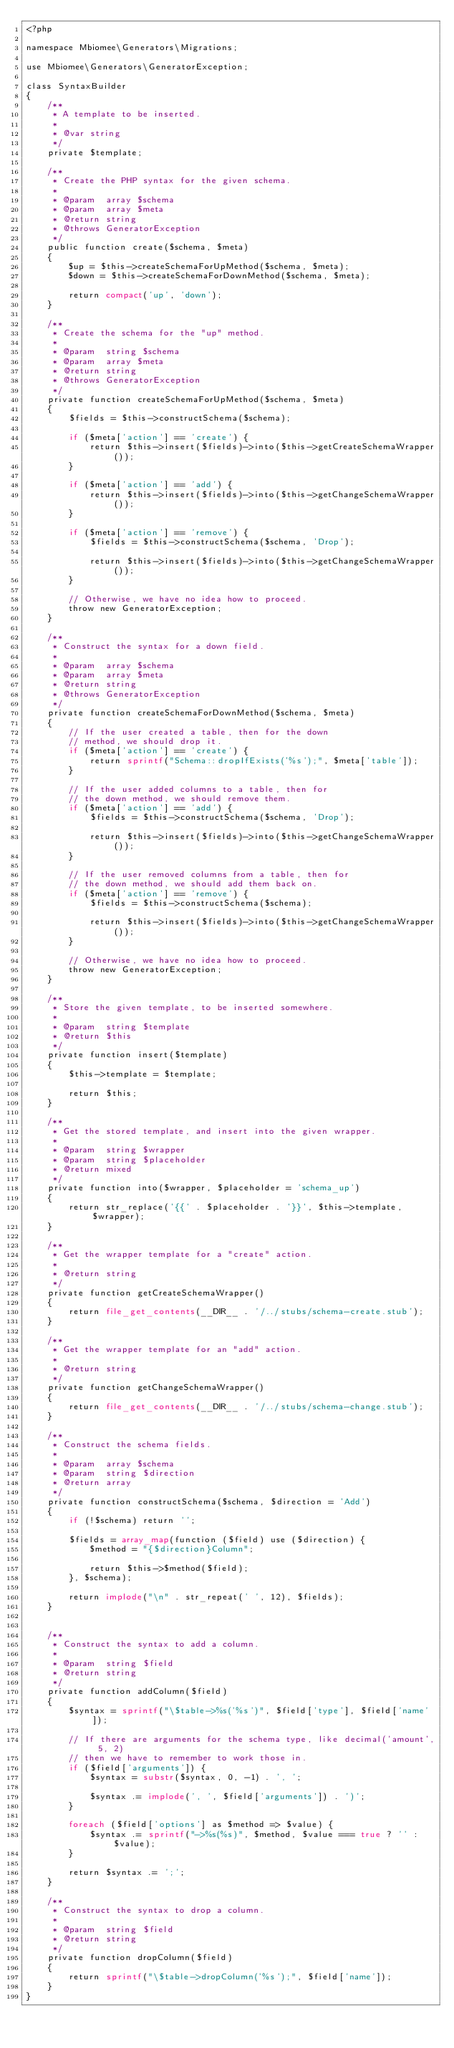<code> <loc_0><loc_0><loc_500><loc_500><_PHP_><?php

namespace Mbiomee\Generators\Migrations;

use Mbiomee\Generators\GeneratorException;

class SyntaxBuilder
{
    /**
     * A template to be inserted.
     *
     * @var string
     */
    private $template;

    /**
     * Create the PHP syntax for the given schema.
     *
     * @param  array $schema
     * @param  array $meta
     * @return string
     * @throws GeneratorException
     */
    public function create($schema, $meta)
    {
        $up = $this->createSchemaForUpMethod($schema, $meta);
        $down = $this->createSchemaForDownMethod($schema, $meta);

        return compact('up', 'down');
    }

    /**
     * Create the schema for the "up" method.
     *
     * @param  string $schema
     * @param  array $meta
     * @return string
     * @throws GeneratorException
     */
    private function createSchemaForUpMethod($schema, $meta)
    {
        $fields = $this->constructSchema($schema);

        if ($meta['action'] == 'create') {
            return $this->insert($fields)->into($this->getCreateSchemaWrapper());
        }

        if ($meta['action'] == 'add') {
            return $this->insert($fields)->into($this->getChangeSchemaWrapper());
        }

        if ($meta['action'] == 'remove') {
            $fields = $this->constructSchema($schema, 'Drop');

            return $this->insert($fields)->into($this->getChangeSchemaWrapper());
        }

        // Otherwise, we have no idea how to proceed.
        throw new GeneratorException;
    }

    /**
     * Construct the syntax for a down field.
     *
     * @param  array $schema
     * @param  array $meta
     * @return string
     * @throws GeneratorException
     */
    private function createSchemaForDownMethod($schema, $meta)
    {
        // If the user created a table, then for the down
        // method, we should drop it.
        if ($meta['action'] == 'create') {
            return sprintf("Schema::dropIfExists('%s');", $meta['table']);
        }

        // If the user added columns to a table, then for
        // the down method, we should remove them.
        if ($meta['action'] == 'add') {
            $fields = $this->constructSchema($schema, 'Drop');

            return $this->insert($fields)->into($this->getChangeSchemaWrapper());
        }

        // If the user removed columns from a table, then for
        // the down method, we should add them back on.
        if ($meta['action'] == 'remove') {
            $fields = $this->constructSchema($schema);

            return $this->insert($fields)->into($this->getChangeSchemaWrapper());
        }

        // Otherwise, we have no idea how to proceed.
        throw new GeneratorException;
    }

    /**
     * Store the given template, to be inserted somewhere.
     *
     * @param  string $template
     * @return $this
     */
    private function insert($template)
    {
        $this->template = $template;

        return $this;
    }

    /**
     * Get the stored template, and insert into the given wrapper.
     *
     * @param  string $wrapper
     * @param  string $placeholder
     * @return mixed
     */
    private function into($wrapper, $placeholder = 'schema_up')
    {
        return str_replace('{{' . $placeholder . '}}', $this->template, $wrapper);
    }

    /**
     * Get the wrapper template for a "create" action.
     *
     * @return string
     */
    private function getCreateSchemaWrapper()
    {
        return file_get_contents(__DIR__ . '/../stubs/schema-create.stub');
    }

    /**
     * Get the wrapper template for an "add" action.
     *
     * @return string
     */
    private function getChangeSchemaWrapper()
    {
        return file_get_contents(__DIR__ . '/../stubs/schema-change.stub');
    }

    /**
     * Construct the schema fields.
     *
     * @param  array $schema
     * @param  string $direction
     * @return array
     */
    private function constructSchema($schema, $direction = 'Add')
    {
        if (!$schema) return '';

        $fields = array_map(function ($field) use ($direction) {
            $method = "{$direction}Column";

            return $this->$method($field);
        }, $schema);

        return implode("\n" . str_repeat(' ', 12), $fields);
    }


    /**
     * Construct the syntax to add a column.
     *
     * @param  string $field
     * @return string
     */
    private function addColumn($field)
    {
        $syntax = sprintf("\$table->%s('%s')", $field['type'], $field['name']);

        // If there are arguments for the schema type, like decimal('amount', 5, 2)
        // then we have to remember to work those in.
        if ($field['arguments']) {
            $syntax = substr($syntax, 0, -1) . ', ';

            $syntax .= implode(', ', $field['arguments']) . ')';
        }

        foreach ($field['options'] as $method => $value) {
            $syntax .= sprintf("->%s(%s)", $method, $value === true ? '' : $value);
        }

        return $syntax .= ';';
    }

    /**
     * Construct the syntax to drop a column.
     *
     * @param  string $field
     * @return string
     */
    private function dropColumn($field)
    {
        return sprintf("\$table->dropColumn('%s');", $field['name']);
    }
}
</code> 